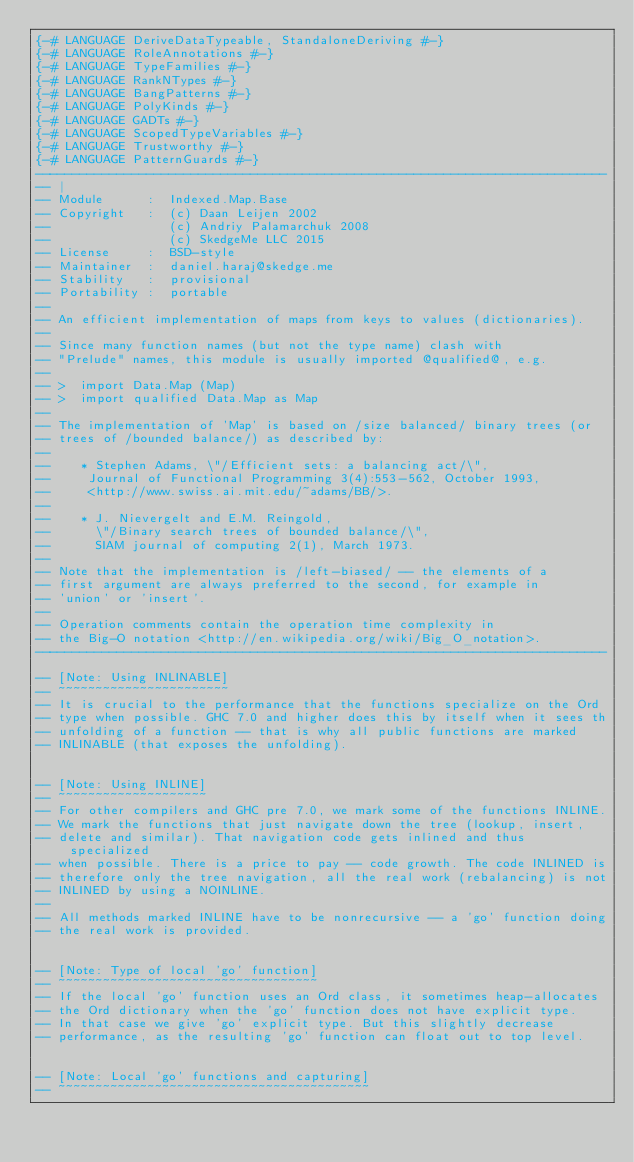Convert code to text. <code><loc_0><loc_0><loc_500><loc_500><_Haskell_>{-# LANGUAGE DeriveDataTypeable, StandaloneDeriving #-}
{-# LANGUAGE RoleAnnotations #-}
{-# LANGUAGE TypeFamilies #-}
{-# LANGUAGE RankNTypes #-}
{-# LANGUAGE BangPatterns #-}
{-# LANGUAGE PolyKinds #-}
{-# LANGUAGE GADTs #-}
{-# LANGUAGE ScopedTypeVariables #-}
{-# LANGUAGE Trustworthy #-}
{-# LANGUAGE PatternGuards #-}
-----------------------------------------------------------------------------
-- |
-- Module      :  Indexed.Map.Base
-- Copyright   :  (c) Daan Leijen 2002
--                (c) Andriy Palamarchuk 2008
--                (c) SkedgeMe LLC 2015
-- License     :  BSD-style
-- Maintainer  :  daniel.haraj@skedge.me
-- Stability   :  provisional
-- Portability :  portable
--
-- An efficient implementation of maps from keys to values (dictionaries).
--
-- Since many function names (but not the type name) clash with
-- "Prelude" names, this module is usually imported @qualified@, e.g.
--
-- >  import Data.Map (Map)
-- >  import qualified Data.Map as Map
--
-- The implementation of 'Map' is based on /size balanced/ binary trees (or
-- trees of /bounded balance/) as described by:
--
--    * Stephen Adams, \"/Efficient sets: a balancing act/\",
--     Journal of Functional Programming 3(4):553-562, October 1993,
--     <http://www.swiss.ai.mit.edu/~adams/BB/>.
--
--    * J. Nievergelt and E.M. Reingold,
--      \"/Binary search trees of bounded balance/\",
--      SIAM journal of computing 2(1), March 1973.
--
-- Note that the implementation is /left-biased/ -- the elements of a
-- first argument are always preferred to the second, for example in
-- 'union' or 'insert'.
--
-- Operation comments contain the operation time complexity in
-- the Big-O notation <http://en.wikipedia.org/wiki/Big_O_notation>.
-----------------------------------------------------------------------------

-- [Note: Using INLINABLE]
-- ~~~~~~~~~~~~~~~~~~~~~~~
-- It is crucial to the performance that the functions specialize on the Ord
-- type when possible. GHC 7.0 and higher does this by itself when it sees th
-- unfolding of a function -- that is why all public functions are marked
-- INLINABLE (that exposes the unfolding).


-- [Note: Using INLINE]
-- ~~~~~~~~~~~~~~~~~~~~
-- For other compilers and GHC pre 7.0, we mark some of the functions INLINE.
-- We mark the functions that just navigate down the tree (lookup, insert,
-- delete and similar). That navigation code gets inlined and thus specialized
-- when possible. There is a price to pay -- code growth. The code INLINED is
-- therefore only the tree navigation, all the real work (rebalancing) is not
-- INLINED by using a NOINLINE.
--
-- All methods marked INLINE have to be nonrecursive -- a 'go' function doing
-- the real work is provided.


-- [Note: Type of local 'go' function]
-- ~~~~~~~~~~~~~~~~~~~~~~~~~~~~~~~~~~~
-- If the local 'go' function uses an Ord class, it sometimes heap-allocates
-- the Ord dictionary when the 'go' function does not have explicit type.
-- In that case we give 'go' explicit type. But this slightly decrease
-- performance, as the resulting 'go' function can float out to top level.


-- [Note: Local 'go' functions and capturing]
-- ~~~~~~~~~~~~~~~~~~~~~~~~~~~~~~~~~~~~~~~~~~</code> 